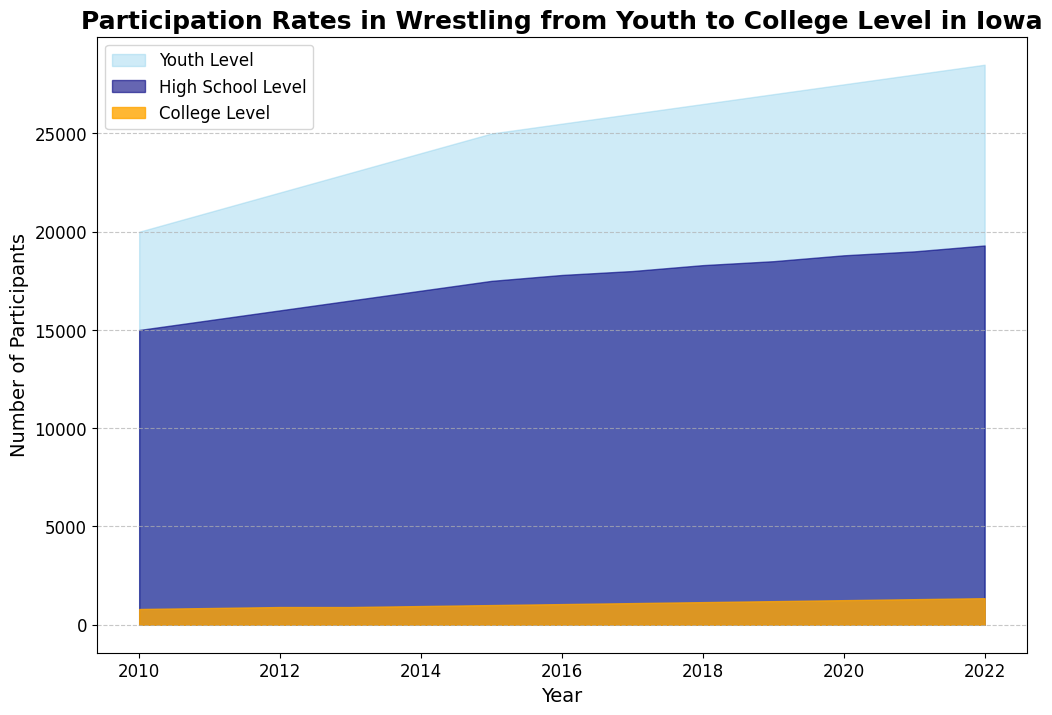What year had the highest number of participants at the Youth Level? To find the year with the highest number of participants at the Youth Level, we visually inspect the chart and notice the highest point in the area corresponding to the Youth Level. The apex happens in 2022.
Answer: 2022 Which level had the fastest growth in participation from 2010 to 2022? By visually comparing the slopes in the graph from 2010 to 2022, the College Level shows the steepest increase over the period, indicating the fastest growth in participation.
Answer: College Level What was the difference in participation between the Youth Level and High School Level in 2022? Locate the endpoints of the Youth Level and High School Level lines in 2022. Subtract the High School Level value (19,300) from the Youth Level value (28,500), which yields 28,500 - 19,300.
Answer: 9,200 How did the High School Level participation trend compare to the Youth Level between 2010 and 2022? By visually examining the rising slopes of both the High School and Youth Levels over the years, both trends show a steady increase, but the Youth Level consistently maintains a higher count than the High School Level in every year.
Answer: Youth Level consistently higher than High School Level What is the percentage increase in participation at the College Level from 2010 to 2022? Read the College Level values for 2010 (800) and 2022 (1,350). Calculate the percentage increase using (1350 - 800) / 800 * 100%. This results in (550 / 800) * 100%.
Answer: 68.75% Which year had the smallest gap between the Youth Level and the High School Level participation? Find the year where the difference between Youth Level and High School Level is the smallest by visually comparing the heights of the two corresponding areas. The smallest gap occurs in 2010.
Answer: 2010 What color represents the College Level participation in the chart? Examine the chart legend where the color designations are provided. The College Level is represented by an orange-colored area in the chart.
Answer: Orange What is the total participation for all levels in 2018? Sum the values of Youth Level (26,500), High School Level (18,300), and College Level (1,150) for 2018. Calculate 26,500 + 18,300 + 1,150.
Answer: 45,950 How does the participation growth in the High School Level between 2010 and 2022 compare to the College Level over the same period? Calculate the absolute increase for High School Level from 15,000 to 19,300, resulting in (19,300 - 15,000 = 4,300). For the College Level, it goes from 800 to 1,350, resulting in (1,350 - 800 = 550). Even though the High School Level increased more in absolute numbers, the College Level showed higher relative growth.
Answer: Higher relative growth in College Level Is there any year where the participation at the Youth Level decreased compared to the previous year? Examine the peaks and slopes of the Youth Level line year-by-year from 2010 to 2022. The trend shows a continuous increase with no decrease year-to-year.
Answer: No 